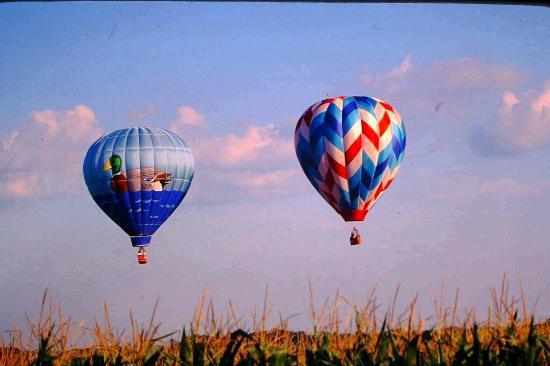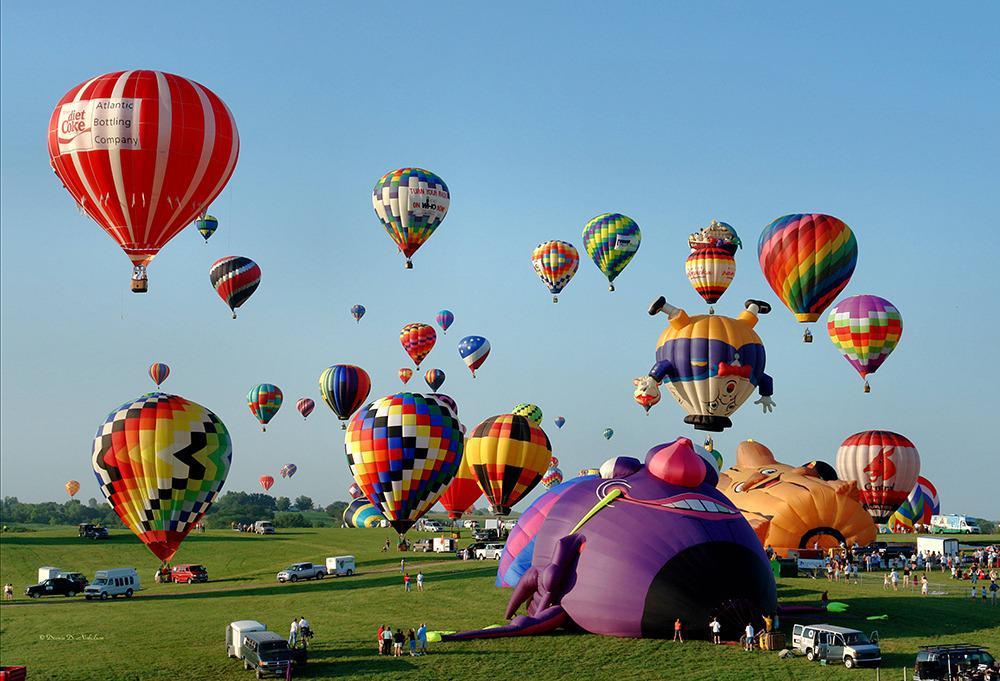The first image is the image on the left, the second image is the image on the right. Examine the images to the left and right. Is the description "The left image features at least one but no more than two hot air balloons in the air a distance from the ground, and the right image includes a hot air balloon that is not in the air." accurate? Answer yes or no. Yes. The first image is the image on the left, the second image is the image on the right. Examine the images to the left and right. Is the description "At least one hot air balloon has a character's face on it." accurate? Answer yes or no. Yes. 